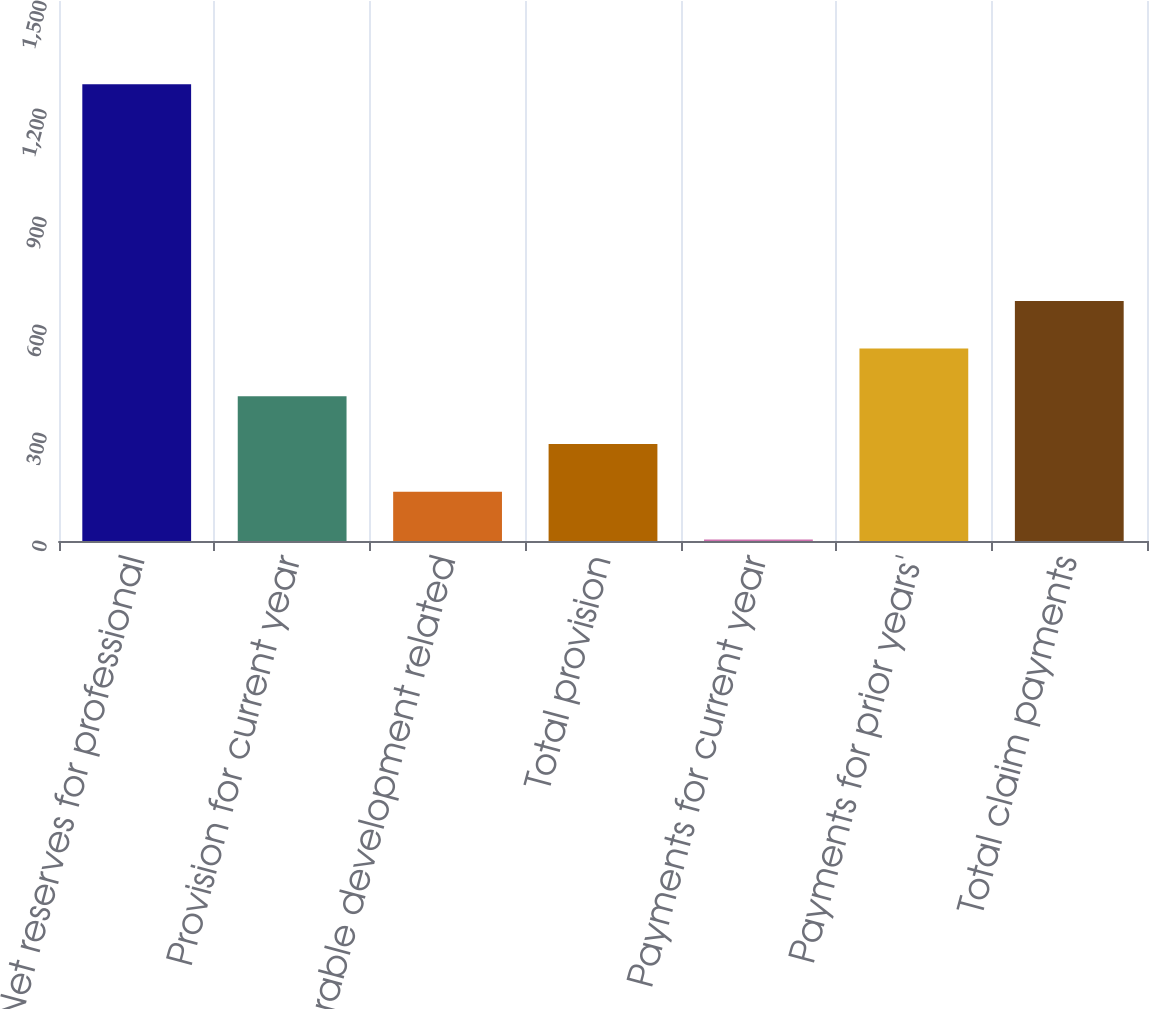<chart> <loc_0><loc_0><loc_500><loc_500><bar_chart><fcel>Net reserves for professional<fcel>Provision for current year<fcel>Favorable development related<fcel>Total provision<fcel>Payments for current year<fcel>Payments for prior years'<fcel>Total claim payments<nl><fcel>1269<fcel>401.8<fcel>136.6<fcel>269.2<fcel>4<fcel>534.4<fcel>667<nl></chart> 